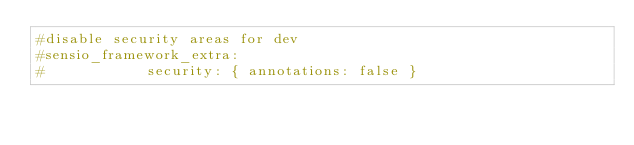Convert code to text. <code><loc_0><loc_0><loc_500><loc_500><_YAML_>#disable security areas for dev
#sensio_framework_extra:
#            security: { annotations: false }
</code> 